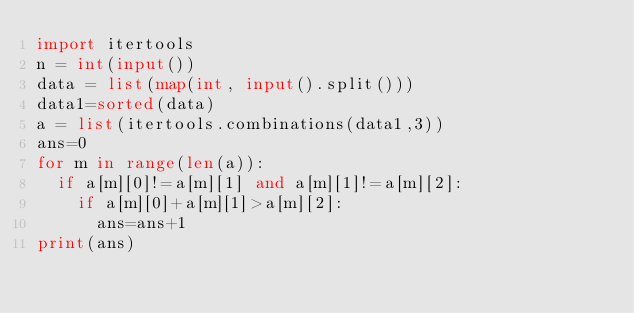Convert code to text. <code><loc_0><loc_0><loc_500><loc_500><_Python_>import itertools
n = int(input())
data = list(map(int, input().split()))
data1=sorted(data)
a = list(itertools.combinations(data1,3))
ans=0
for m in range(len(a)):
  if a[m][0]!=a[m][1] and a[m][1]!=a[m][2]:
    if a[m][0]+a[m][1]>a[m][2]:
      ans=ans+1
print(ans)</code> 